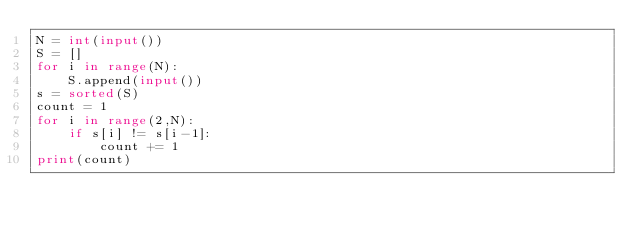<code> <loc_0><loc_0><loc_500><loc_500><_Python_>N = int(input())
S = []
for i in range(N):
    S.append(input())
s = sorted(S)
count = 1
for i in range(2,N):
    if s[i] != s[i-1]:
        count += 1
print(count)</code> 